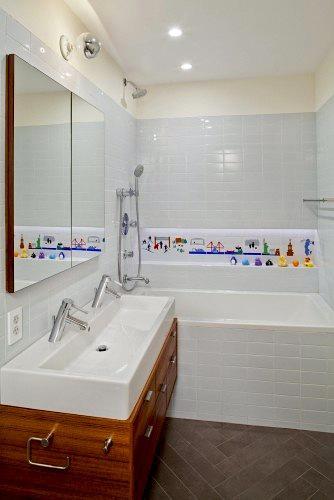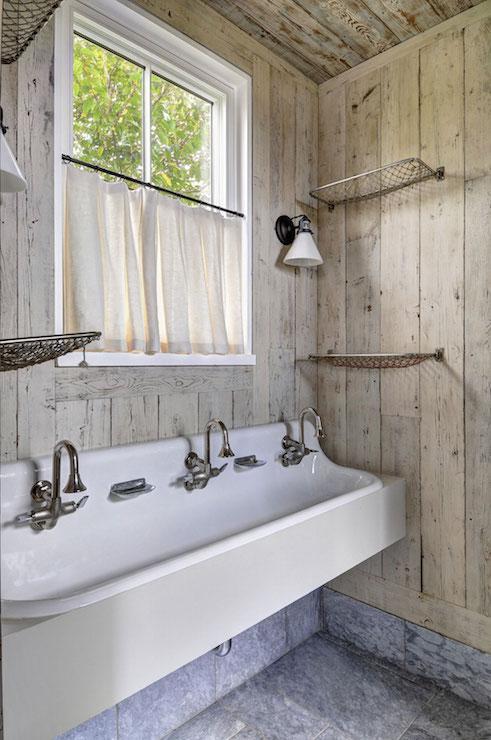The first image is the image on the left, the second image is the image on the right. For the images displayed, is the sentence "One of these images contains two or more footstools, in front of a large sink with multiple faucets." factually correct? Answer yes or no. No. The first image is the image on the left, the second image is the image on the right. Considering the images on both sides, is "porcelain sinks are colored underneath" valid? Answer yes or no. No. 